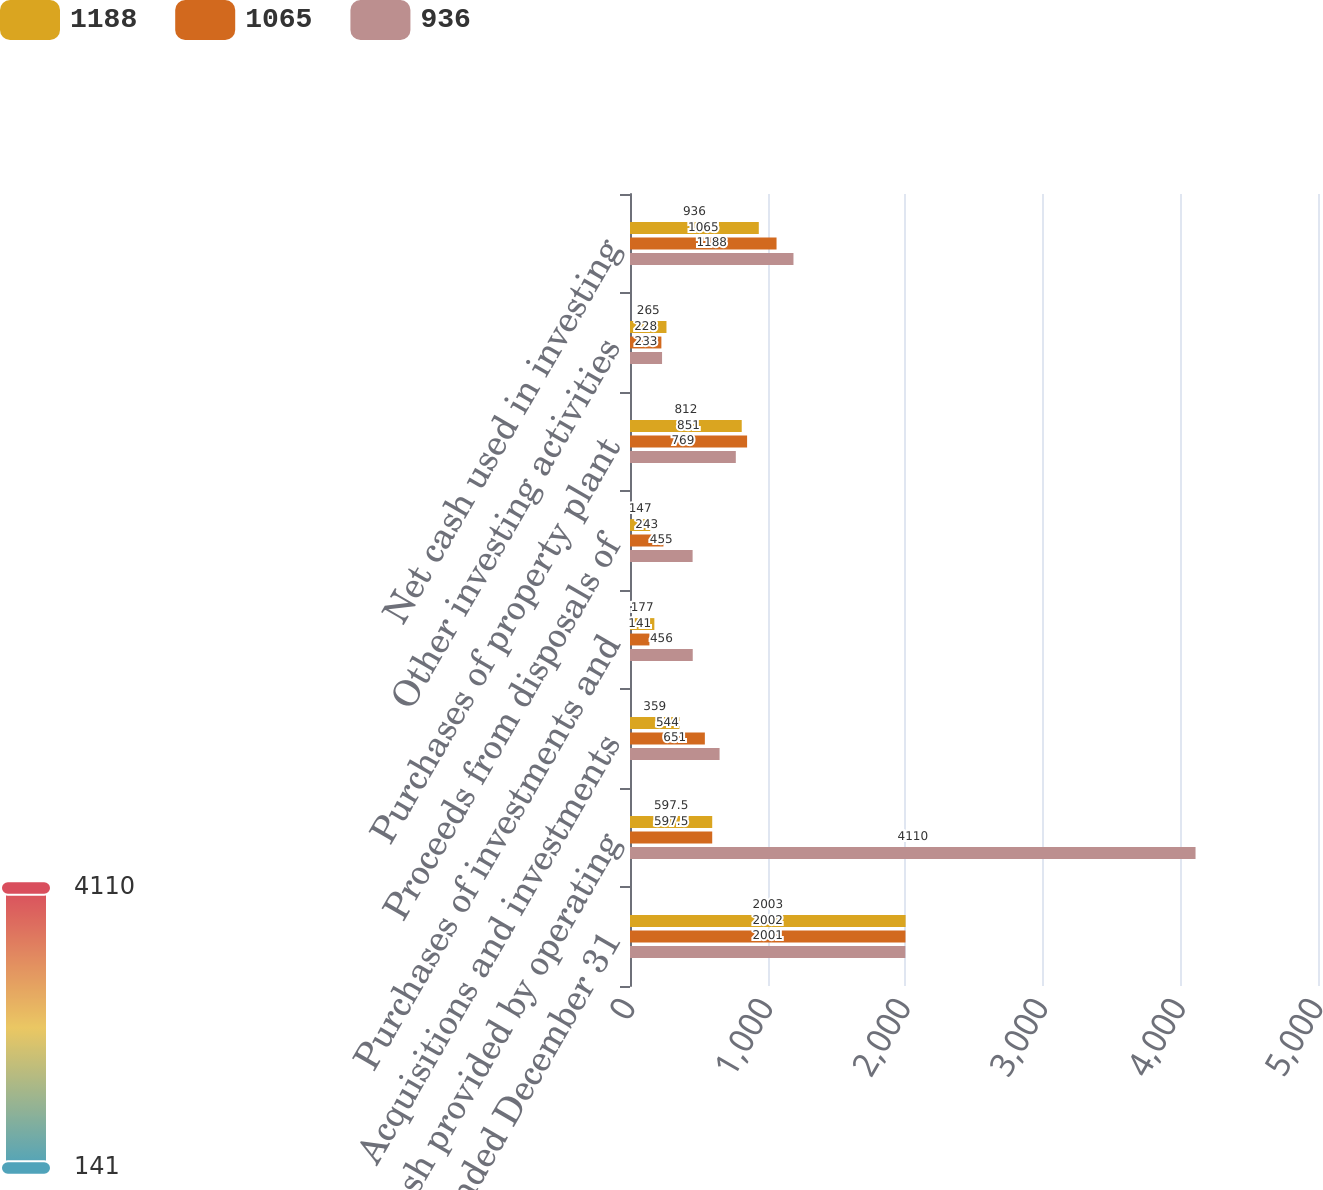Convert chart to OTSL. <chart><loc_0><loc_0><loc_500><loc_500><stacked_bar_chart><ecel><fcel>Year Ended December 31<fcel>Net cash provided by operating<fcel>Acquisitions and investments<fcel>Purchases of investments and<fcel>Proceeds from disposals of<fcel>Purchases of property plant<fcel>Other investing activities<fcel>Net cash used in investing<nl><fcel>1188<fcel>2003<fcel>597.5<fcel>359<fcel>177<fcel>147<fcel>812<fcel>265<fcel>936<nl><fcel>1065<fcel>2002<fcel>597.5<fcel>544<fcel>141<fcel>243<fcel>851<fcel>228<fcel>1065<nl><fcel>936<fcel>2001<fcel>4110<fcel>651<fcel>456<fcel>455<fcel>769<fcel>233<fcel>1188<nl></chart> 